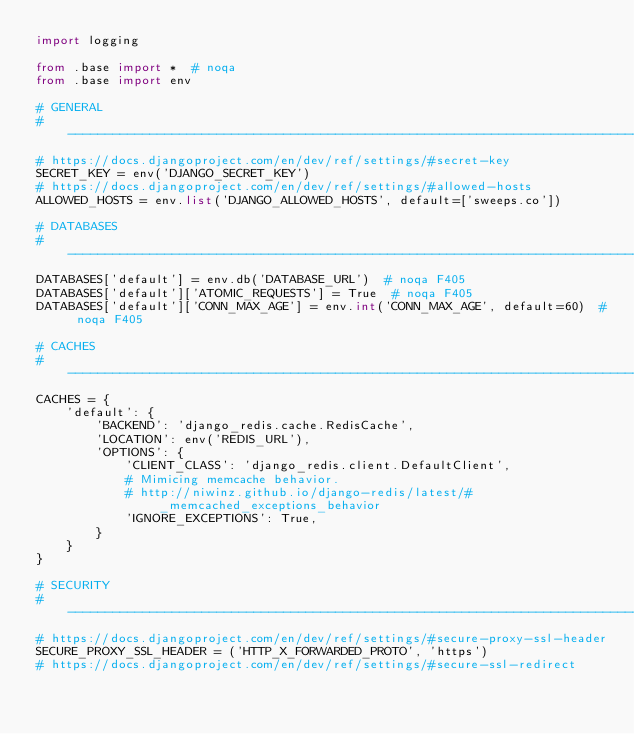Convert code to text. <code><loc_0><loc_0><loc_500><loc_500><_Python_>import logging

from .base import *  # noqa
from .base import env

# GENERAL
# ------------------------------------------------------------------------------
# https://docs.djangoproject.com/en/dev/ref/settings/#secret-key
SECRET_KEY = env('DJANGO_SECRET_KEY')
# https://docs.djangoproject.com/en/dev/ref/settings/#allowed-hosts
ALLOWED_HOSTS = env.list('DJANGO_ALLOWED_HOSTS', default=['sweeps.co'])

# DATABASES
# ------------------------------------------------------------------------------
DATABASES['default'] = env.db('DATABASE_URL')  # noqa F405
DATABASES['default']['ATOMIC_REQUESTS'] = True  # noqa F405
DATABASES['default']['CONN_MAX_AGE'] = env.int('CONN_MAX_AGE', default=60)  # noqa F405

# CACHES
# ------------------------------------------------------------------------------
CACHES = {
    'default': {
        'BACKEND': 'django_redis.cache.RedisCache',
        'LOCATION': env('REDIS_URL'),
        'OPTIONS': {
            'CLIENT_CLASS': 'django_redis.client.DefaultClient',
            # Mimicing memcache behavior.
            # http://niwinz.github.io/django-redis/latest/#_memcached_exceptions_behavior
            'IGNORE_EXCEPTIONS': True,
        }
    }
}

# SECURITY
# ------------------------------------------------------------------------------
# https://docs.djangoproject.com/en/dev/ref/settings/#secure-proxy-ssl-header
SECURE_PROXY_SSL_HEADER = ('HTTP_X_FORWARDED_PROTO', 'https')
# https://docs.djangoproject.com/en/dev/ref/settings/#secure-ssl-redirect</code> 